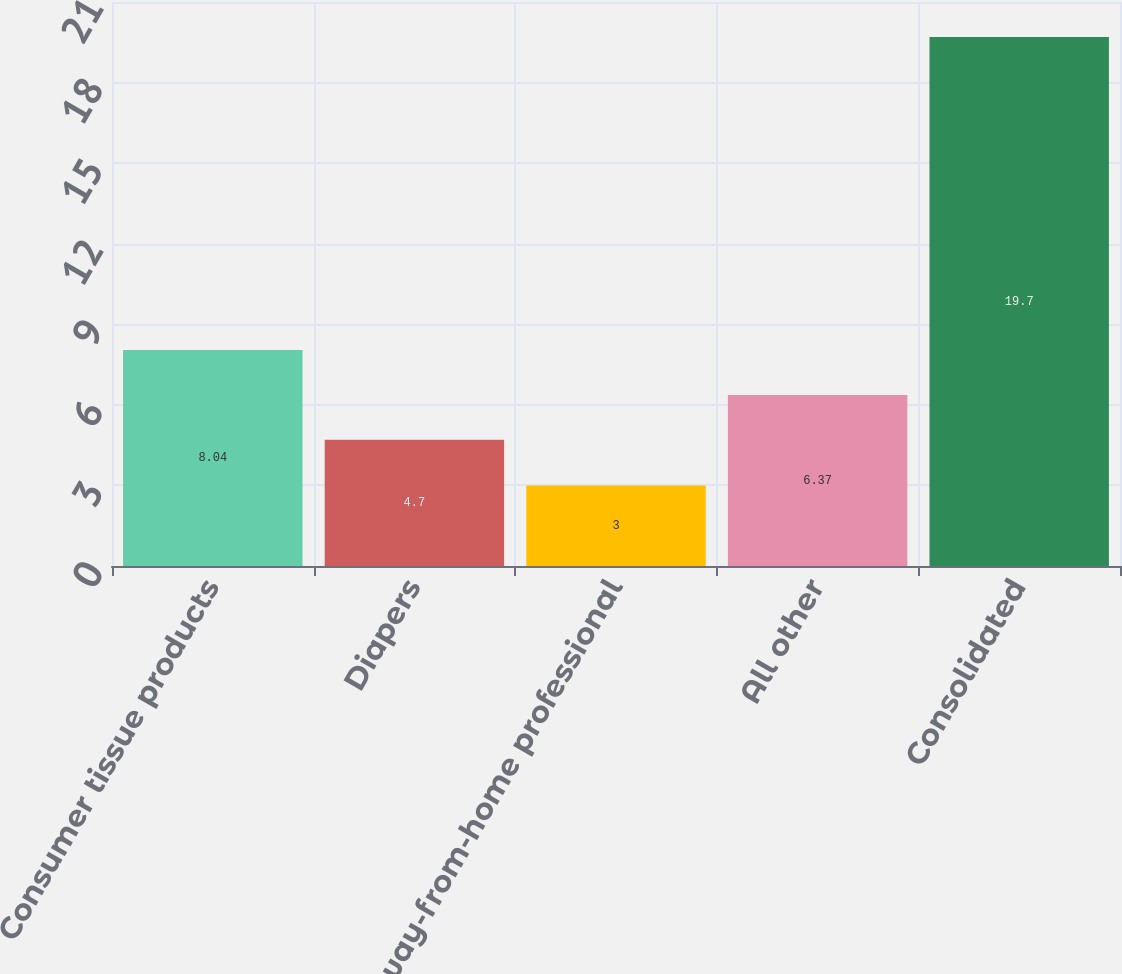Convert chart. <chart><loc_0><loc_0><loc_500><loc_500><bar_chart><fcel>Consumer tissue products<fcel>Diapers<fcel>Away-from-home professional<fcel>All other<fcel>Consolidated<nl><fcel>8.04<fcel>4.7<fcel>3<fcel>6.37<fcel>19.7<nl></chart> 